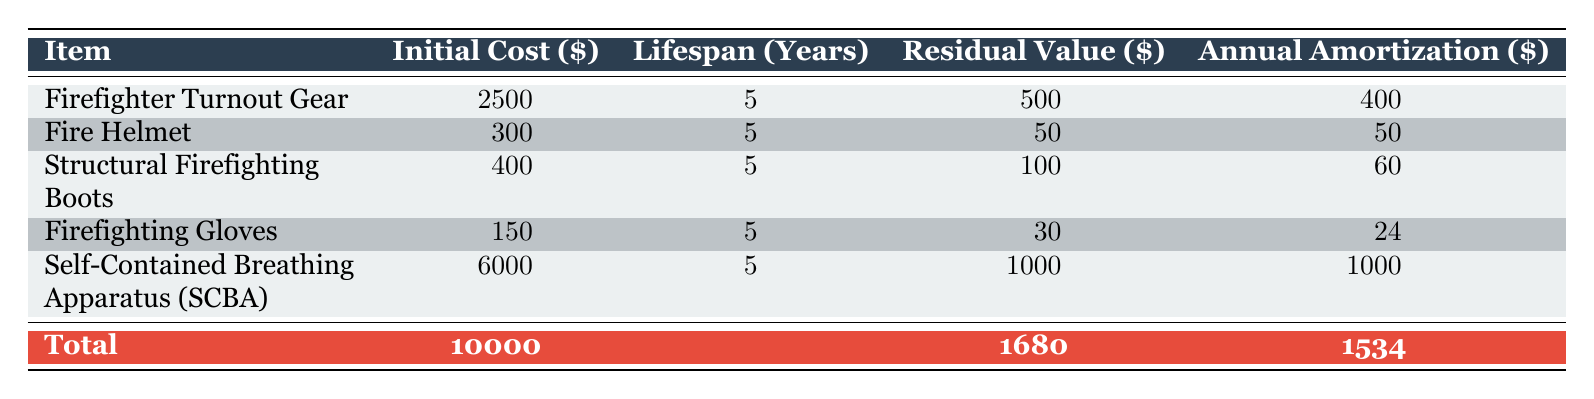What is the initial cost of the Firefighter Turnout Gear? The table lists the initial cost of the Firefighter Turnout Gear as 2500.
Answer: 2500 How long is the lifespan of the Self-Contained Breathing Apparatus (SCBA)? The lifespan of the SCBA is shown in the table as 5 years.
Answer: 5 years What is the total initial cost of all firefighter equipment? To find the total initial cost, refer to the total row at the bottom of the table, which shows it as 10000.
Answer: 10000 What is the total annual amortization for all equipment? The total annual amortization is provided in the total row of the table, which indicates it is 1534.
Answer: 1534 Is the annual amortization for Firefighting Gloves higher than the annual amortization for Fire Helmet? The annual amortization for Firefighting Gloves is 24 and for Fire Helmet is 50. Since 24 is less than 50, the statement is false.
Answer: No Which item has the highest annual amortization? Looking at the table, the Self-Contained Breathing Apparatus (SCBA) has the highest annual amortization of 1000.
Answer: Self-Contained Breathing Apparatus (SCBA) What is the average annual amortization for the items listed? To calculate the average, sum the annual amortizations: 400 + 50 + 60 + 24 + 1000 = 1534. Then divide by the number of items (5) to get 1534 / 5 = 306.8.
Answer: 306.8 How much will the total amortization amount to over the 5-year period? The total amortization over the 5 years is directly stated in the table as 7670.
Answer: 7670 If a piece of equipment has a residual value of 100, which item does it represent? The only item with a residual value of 100 listed in the table is the Structural Firefighting Boots.
Answer: Structural Firefighting Boots 